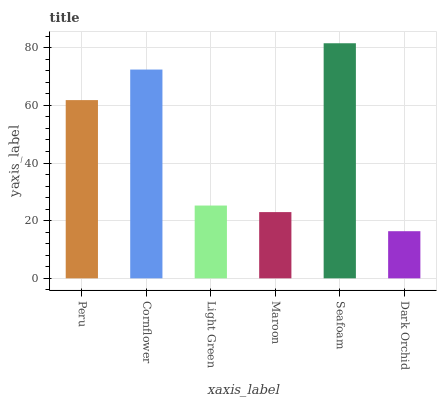Is Dark Orchid the minimum?
Answer yes or no. Yes. Is Seafoam the maximum?
Answer yes or no. Yes. Is Cornflower the minimum?
Answer yes or no. No. Is Cornflower the maximum?
Answer yes or no. No. Is Cornflower greater than Peru?
Answer yes or no. Yes. Is Peru less than Cornflower?
Answer yes or no. Yes. Is Peru greater than Cornflower?
Answer yes or no. No. Is Cornflower less than Peru?
Answer yes or no. No. Is Peru the high median?
Answer yes or no. Yes. Is Light Green the low median?
Answer yes or no. Yes. Is Dark Orchid the high median?
Answer yes or no. No. Is Dark Orchid the low median?
Answer yes or no. No. 